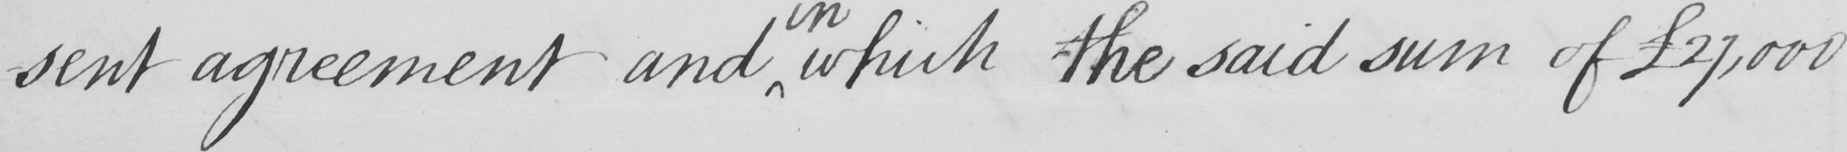What is written in this line of handwriting? sent agreement and which the said sum of  £27,000 